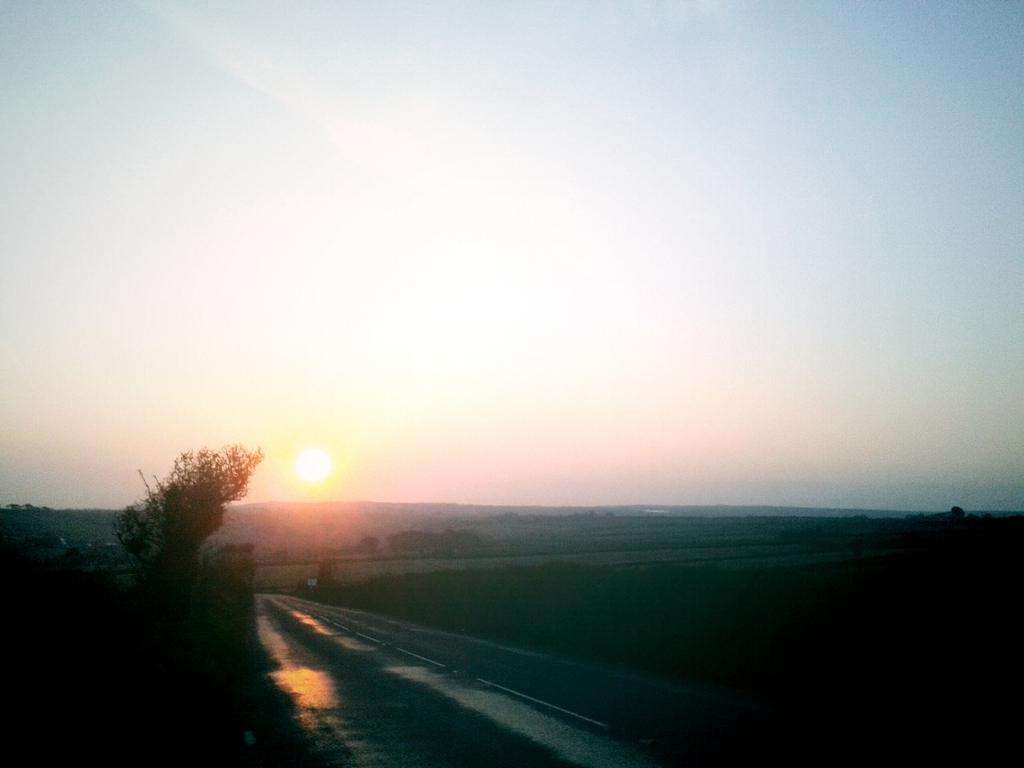What is the main feature of the image? There is a road in the image. What can be seen beside the road? There is a grass surface beside the road. Are there any plants visible in the image? Yes, there are plants near the road. What is visible in the background of the image? There are trees and hills in the background of the image. What is visible in the sky in the image? The sky is visible in the image, and the sun is visible in the sky. What type of sugar treatment is being applied to the trees in the image? There is no sugar treatment being applied to the trees in the image; the trees are simply part of the background. Can you see any kisses being exchanged between the trees in the image? There are no kisses being exchanged between the trees in the image; trees do not have the ability to kiss. 